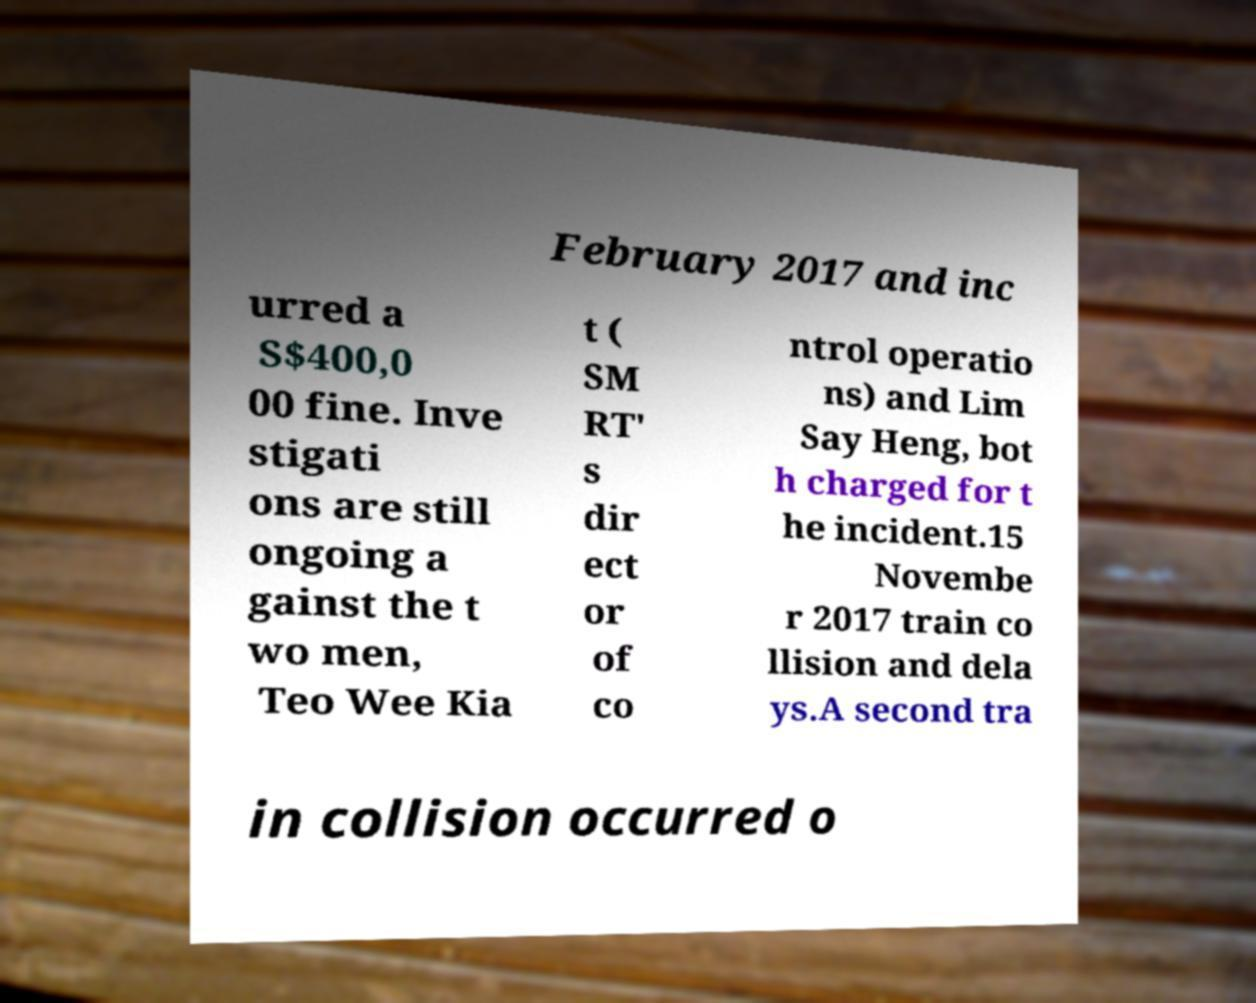Could you assist in decoding the text presented in this image and type it out clearly? February 2017 and inc urred a S$400,0 00 fine. Inve stigati ons are still ongoing a gainst the t wo men, Teo Wee Kia t ( SM RT' s dir ect or of co ntrol operatio ns) and Lim Say Heng, bot h charged for t he incident.15 Novembe r 2017 train co llision and dela ys.A second tra in collision occurred o 